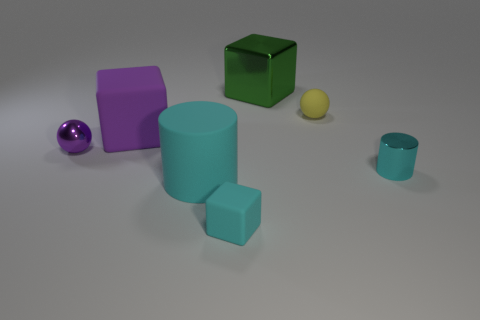Add 3 tiny shiny spheres. How many objects exist? 10 Subtract all cubes. How many objects are left? 4 Subtract 0 blue cubes. How many objects are left? 7 Subtract all cyan objects. Subtract all large brown rubber objects. How many objects are left? 4 Add 3 tiny things. How many tiny things are left? 7 Add 4 cyan metallic cylinders. How many cyan metallic cylinders exist? 5 